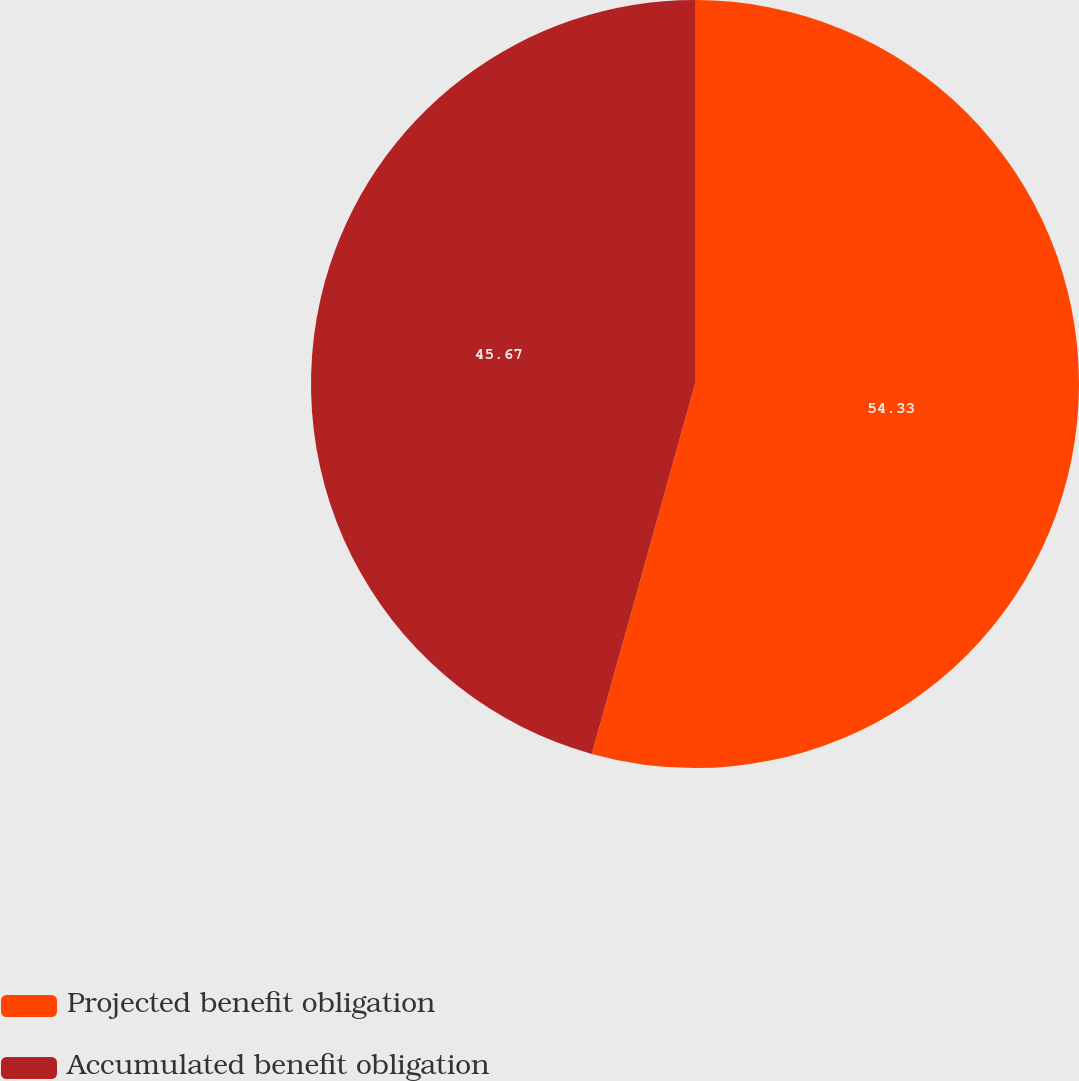Convert chart. <chart><loc_0><loc_0><loc_500><loc_500><pie_chart><fcel>Projected benefit obligation<fcel>Accumulated benefit obligation<nl><fcel>54.33%<fcel>45.67%<nl></chart> 